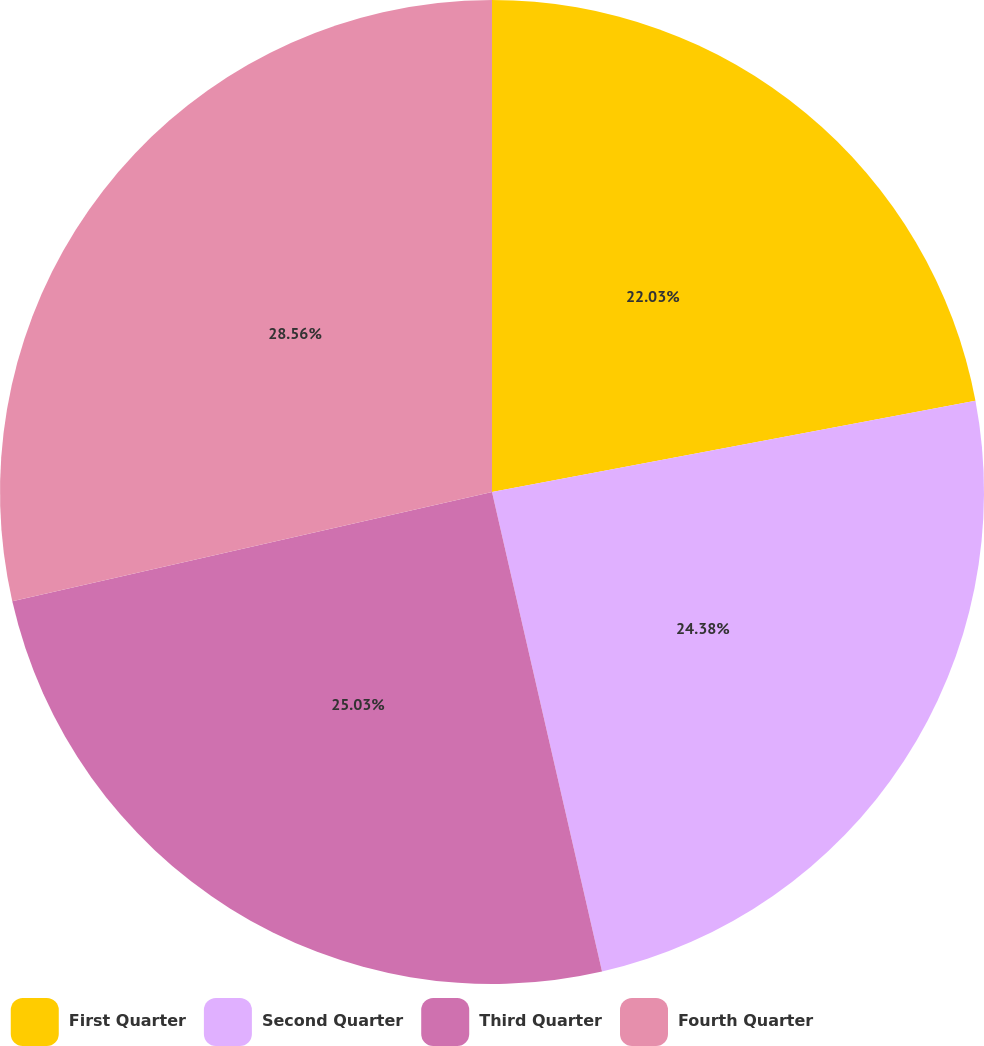Convert chart. <chart><loc_0><loc_0><loc_500><loc_500><pie_chart><fcel>First Quarter<fcel>Second Quarter<fcel>Third Quarter<fcel>Fourth Quarter<nl><fcel>22.03%<fcel>24.38%<fcel>25.03%<fcel>28.56%<nl></chart> 